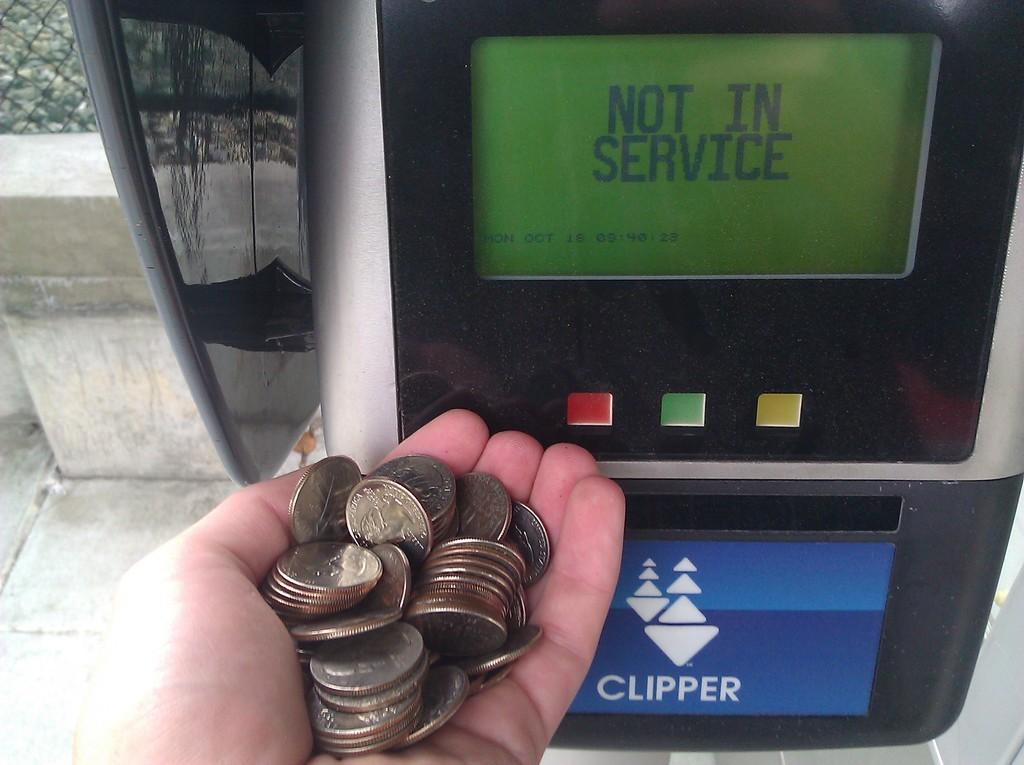Provide a one-sentence caption for the provided image. A person with a handful of coins by a meter that is out of service. 